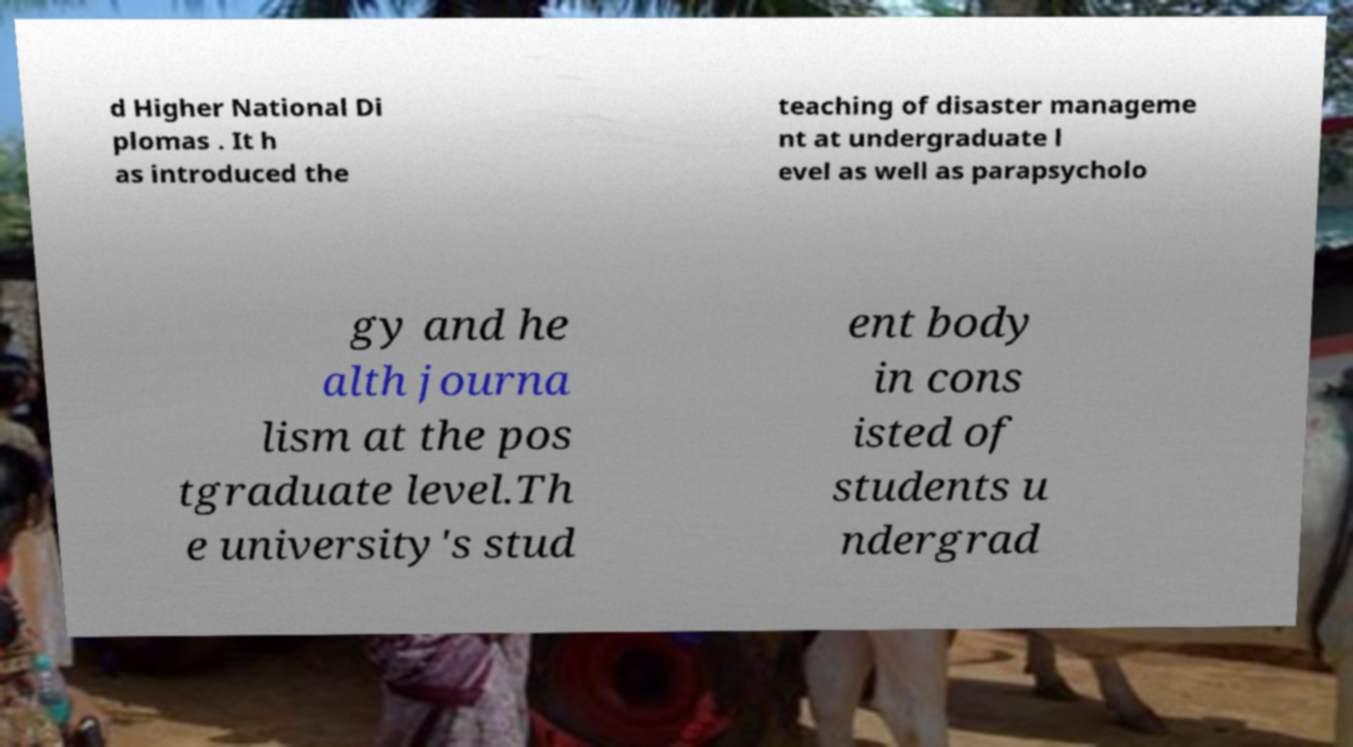Please read and relay the text visible in this image. What does it say? d Higher National Di plomas . It h as introduced the teaching of disaster manageme nt at undergraduate l evel as well as parapsycholo gy and he alth journa lism at the pos tgraduate level.Th e university's stud ent body in cons isted of students u ndergrad 